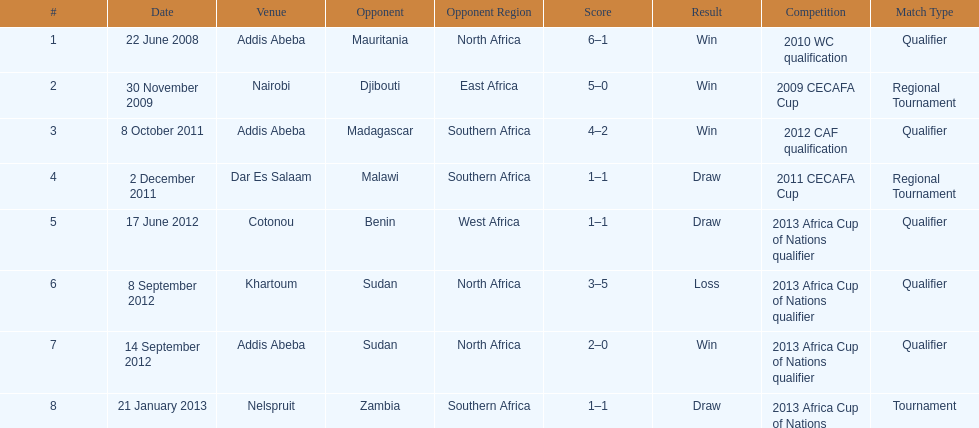What date gives was their only loss? 8 September 2012. 